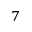Convert formula to latex. <formula><loc_0><loc_0><loc_500><loc_500>^ { 7 }</formula> 